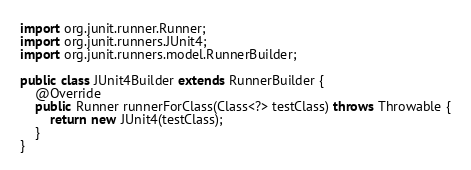<code> <loc_0><loc_0><loc_500><loc_500><_Java_>
import org.junit.runner.Runner;
import org.junit.runners.JUnit4;
import org.junit.runners.model.RunnerBuilder;

public class JUnit4Builder extends RunnerBuilder {
    @Override
    public Runner runnerForClass(Class<?> testClass) throws Throwable {
        return new JUnit4(testClass);
    }
}
</code> 